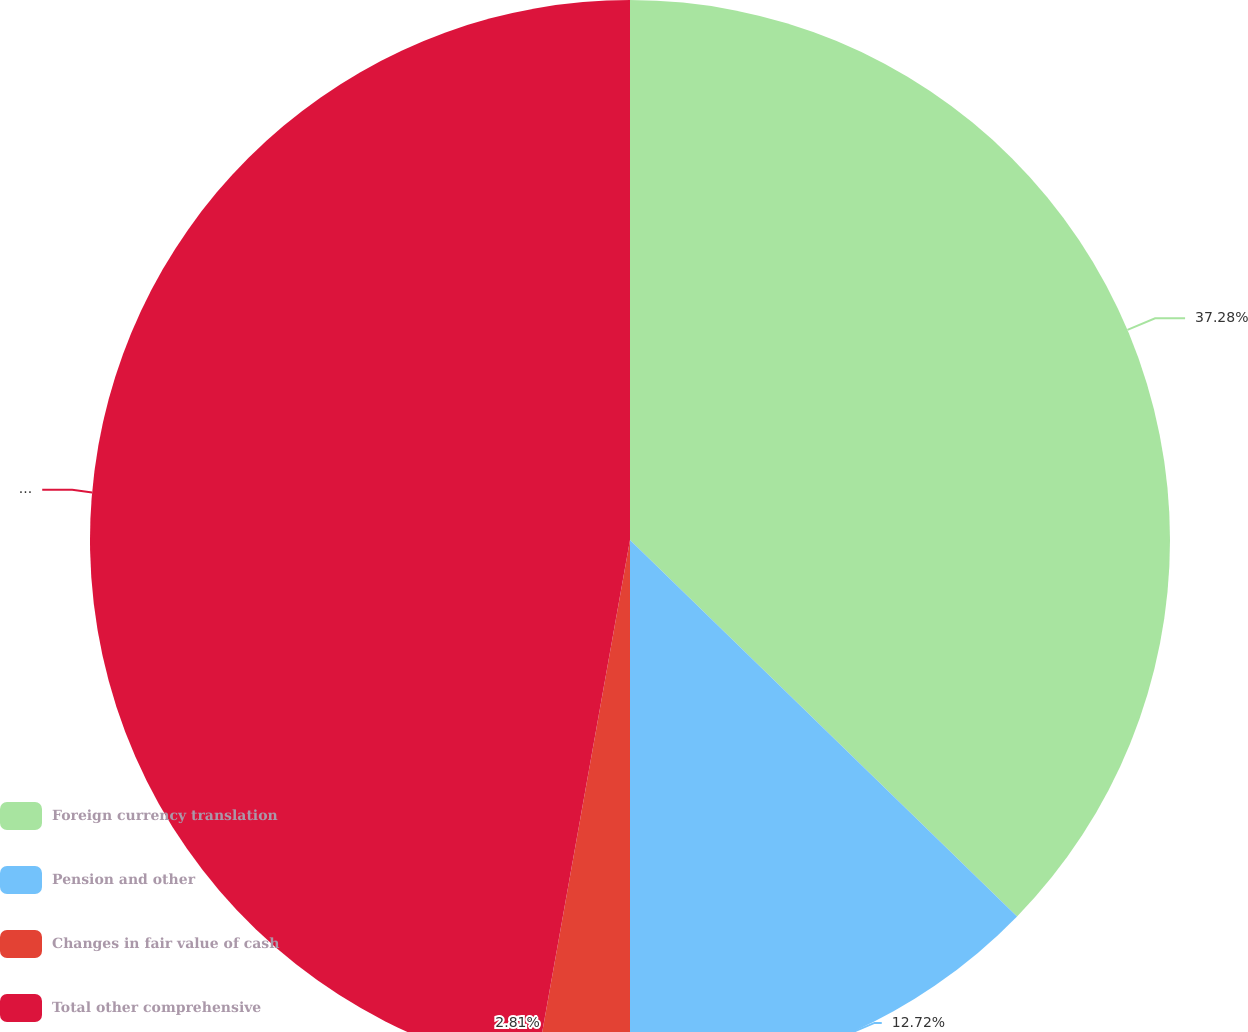Convert chart. <chart><loc_0><loc_0><loc_500><loc_500><pie_chart><fcel>Foreign currency translation<fcel>Pension and other<fcel>Changes in fair value of cash<fcel>Total other comprehensive<nl><fcel>37.28%<fcel>12.72%<fcel>2.81%<fcel>47.19%<nl></chart> 